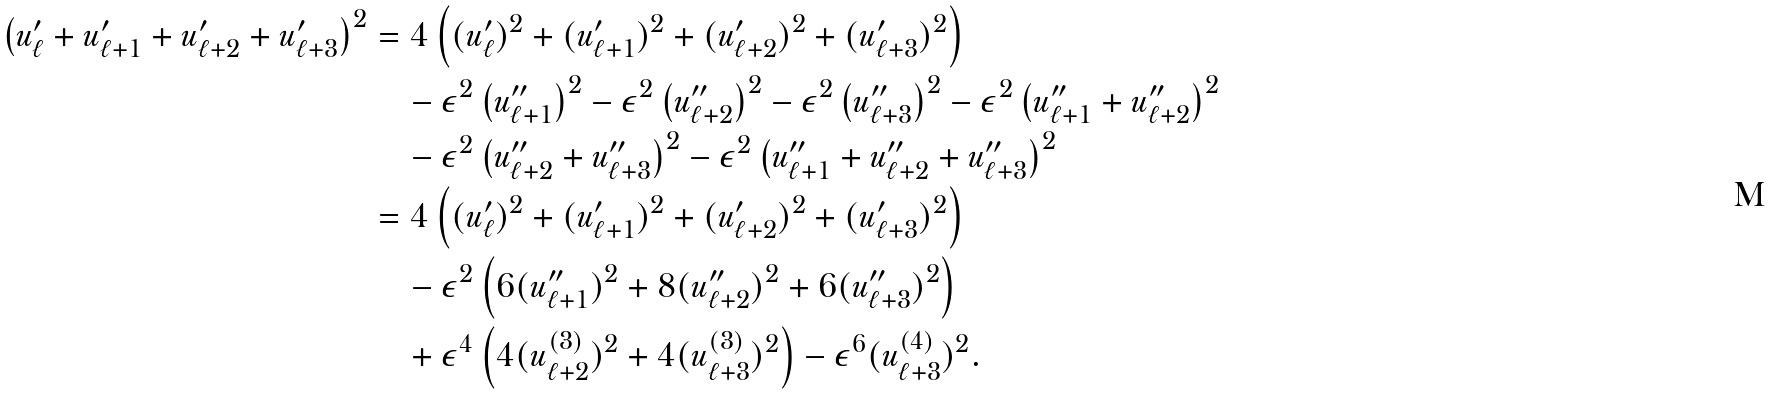<formula> <loc_0><loc_0><loc_500><loc_500>\left ( u ^ { \prime } _ { \ell } + u ^ { \prime } _ { \ell + 1 } + u ^ { \prime } _ { \ell + 2 } + u ^ { \prime } _ { \ell + 3 } \right ) ^ { 2 } & = 4 \left ( ( u ^ { \prime } _ { \ell } ) ^ { 2 } + ( u ^ { \prime } _ { \ell + 1 } ) ^ { 2 } + ( u ^ { \prime } _ { \ell + 2 } ) ^ { 2 } + ( u ^ { \prime } _ { \ell + 3 } ) ^ { 2 } \right ) \\ & \quad - \epsilon ^ { 2 } \left ( u ^ { \prime \prime } _ { \ell + 1 } \right ) ^ { 2 } - \epsilon ^ { 2 } \left ( u ^ { \prime \prime } _ { \ell + 2 } \right ) ^ { 2 } - \epsilon ^ { 2 } \left ( u ^ { \prime \prime } _ { \ell + 3 } \right ) ^ { 2 } - \epsilon ^ { 2 } \left ( u ^ { \prime \prime } _ { \ell + 1 } + u ^ { \prime \prime } _ { \ell + 2 } \right ) ^ { 2 } \\ & \quad - \epsilon ^ { 2 } \left ( u ^ { \prime \prime } _ { \ell + 2 } + u ^ { \prime \prime } _ { \ell + 3 } \right ) ^ { 2 } - \epsilon ^ { 2 } \left ( u ^ { \prime \prime } _ { \ell + 1 } + u ^ { \prime \prime } _ { \ell + 2 } + u ^ { \prime \prime } _ { \ell + 3 } \right ) ^ { 2 } \\ & = 4 \left ( ( u ^ { \prime } _ { \ell } ) ^ { 2 } + ( u ^ { \prime } _ { \ell + 1 } ) ^ { 2 } + ( u ^ { \prime } _ { \ell + 2 } ) ^ { 2 } + ( u ^ { \prime } _ { \ell + 3 } ) ^ { 2 } \right ) \\ & \quad - \epsilon ^ { 2 } \left ( 6 ( u ^ { \prime \prime } _ { \ell + 1 } ) ^ { 2 } + 8 ( u ^ { \prime \prime } _ { \ell + 2 } ) ^ { 2 } + 6 ( u ^ { \prime \prime } _ { \ell + 3 } ) ^ { 2 } \right ) \\ & \quad + \epsilon ^ { 4 } \left ( 4 ( u ^ { ( 3 ) } _ { \ell + 2 } ) ^ { 2 } + 4 ( u ^ { ( 3 ) } _ { \ell + 3 } ) ^ { 2 } \right ) - \epsilon ^ { 6 } ( u ^ { ( 4 ) } _ { \ell + 3 } ) ^ { 2 } .</formula> 